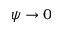Convert formula to latex. <formula><loc_0><loc_0><loc_500><loc_500>\psi \rightarrow 0</formula> 